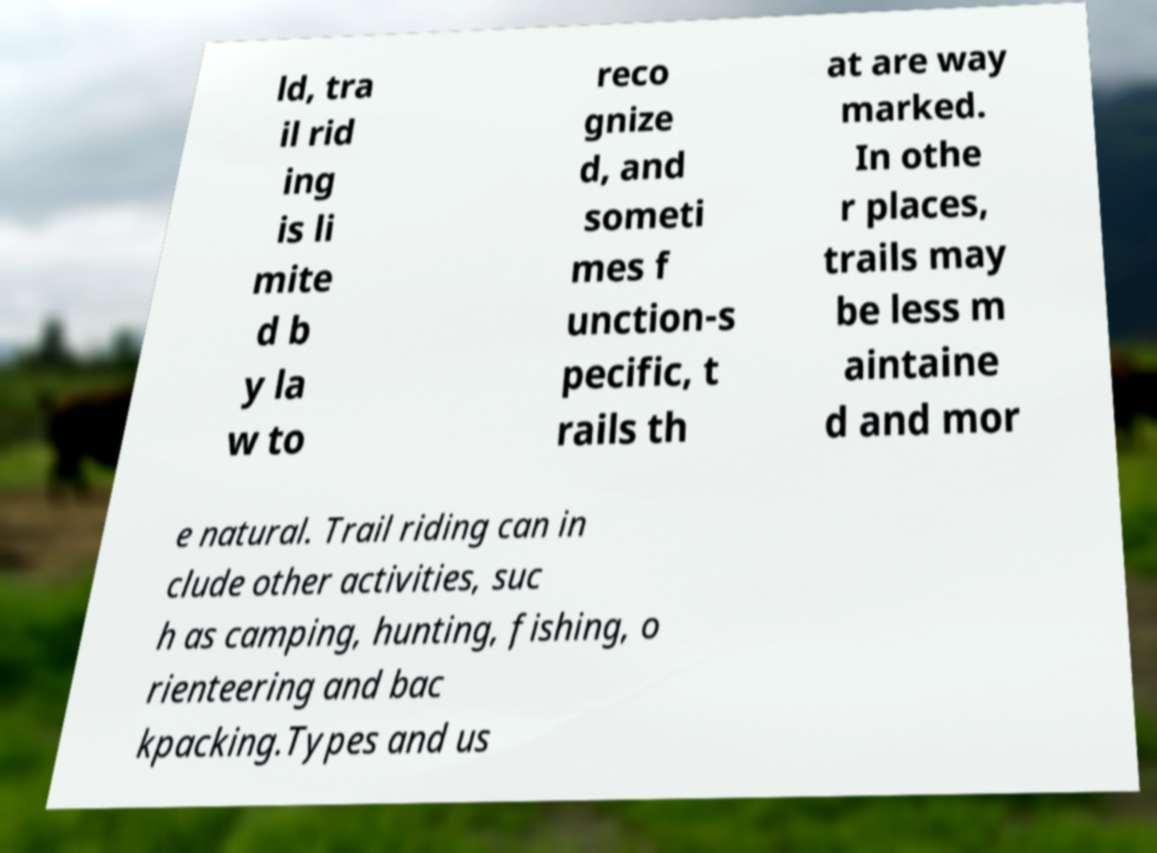What messages or text are displayed in this image? I need them in a readable, typed format. ld, tra il rid ing is li mite d b y la w to reco gnize d, and someti mes f unction-s pecific, t rails th at are way marked. In othe r places, trails may be less m aintaine d and mor e natural. Trail riding can in clude other activities, suc h as camping, hunting, fishing, o rienteering and bac kpacking.Types and us 